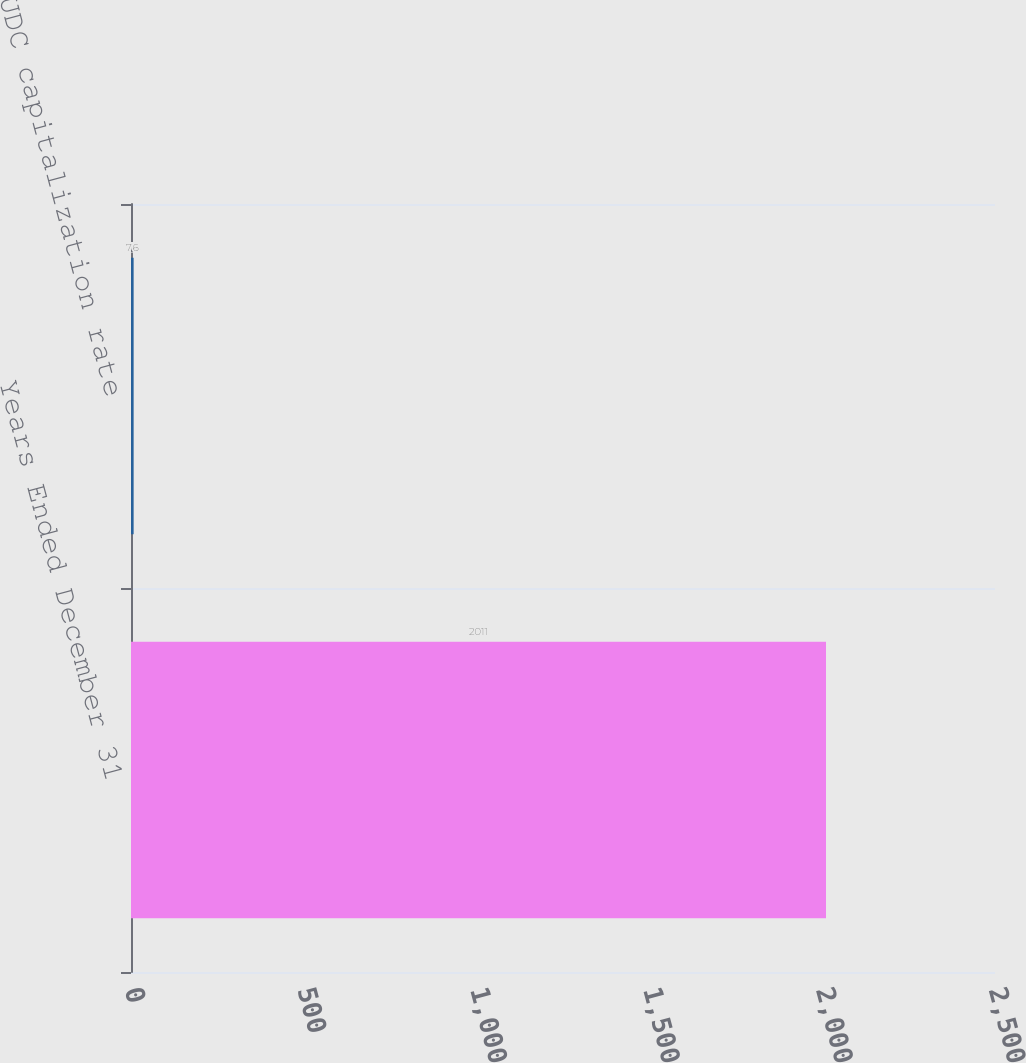Convert chart. <chart><loc_0><loc_0><loc_500><loc_500><bar_chart><fcel>Years Ended December 31<fcel>AFUDC capitalization rate<nl><fcel>2011<fcel>7.6<nl></chart> 